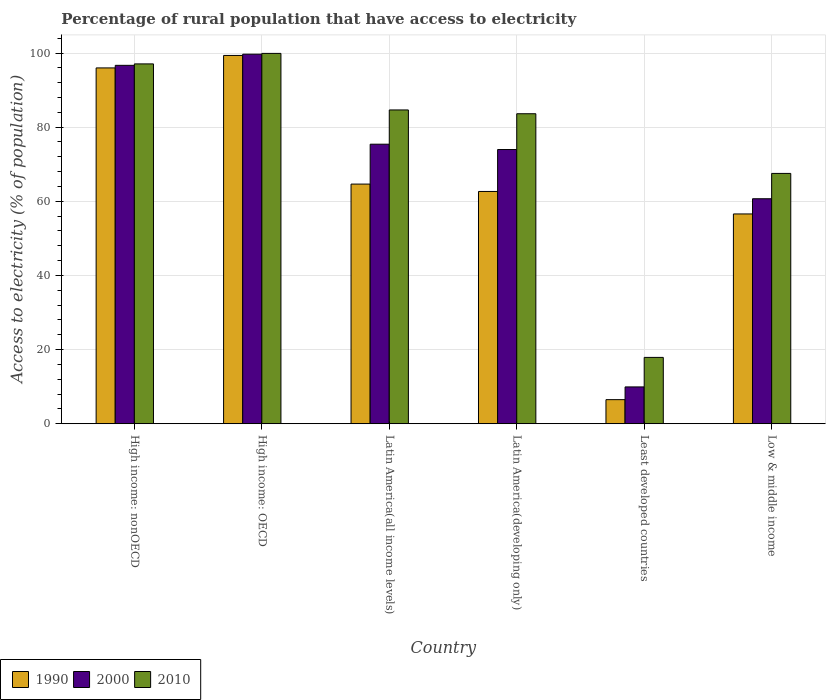How many different coloured bars are there?
Your answer should be very brief. 3. Are the number of bars on each tick of the X-axis equal?
Make the answer very short. Yes. How many bars are there on the 1st tick from the right?
Provide a succinct answer. 3. What is the label of the 5th group of bars from the left?
Make the answer very short. Least developed countries. In how many cases, is the number of bars for a given country not equal to the number of legend labels?
Provide a short and direct response. 0. What is the percentage of rural population that have access to electricity in 1990 in Least developed countries?
Your answer should be compact. 6.5. Across all countries, what is the maximum percentage of rural population that have access to electricity in 1990?
Provide a short and direct response. 99.34. Across all countries, what is the minimum percentage of rural population that have access to electricity in 1990?
Your response must be concise. 6.5. In which country was the percentage of rural population that have access to electricity in 1990 maximum?
Your answer should be very brief. High income: OECD. In which country was the percentage of rural population that have access to electricity in 2010 minimum?
Your answer should be compact. Least developed countries. What is the total percentage of rural population that have access to electricity in 1990 in the graph?
Your answer should be very brief. 385.7. What is the difference between the percentage of rural population that have access to electricity in 2000 in Least developed countries and that in Low & middle income?
Ensure brevity in your answer.  -50.76. What is the difference between the percentage of rural population that have access to electricity in 2000 in Low & middle income and the percentage of rural population that have access to electricity in 1990 in High income: nonOECD?
Keep it short and to the point. -35.29. What is the average percentage of rural population that have access to electricity in 1990 per country?
Keep it short and to the point. 64.28. What is the difference between the percentage of rural population that have access to electricity of/in 2000 and percentage of rural population that have access to electricity of/in 2010 in Latin America(all income levels)?
Keep it short and to the point. -9.24. In how many countries, is the percentage of rural population that have access to electricity in 2000 greater than 76 %?
Your answer should be very brief. 2. What is the ratio of the percentage of rural population that have access to electricity in 1990 in High income: OECD to that in High income: nonOECD?
Offer a terse response. 1.04. Is the percentage of rural population that have access to electricity in 1990 in High income: nonOECD less than that in Low & middle income?
Provide a short and direct response. No. What is the difference between the highest and the second highest percentage of rural population that have access to electricity in 2000?
Offer a very short reply. 21.27. What is the difference between the highest and the lowest percentage of rural population that have access to electricity in 2000?
Your answer should be very brief. 89.75. In how many countries, is the percentage of rural population that have access to electricity in 2000 greater than the average percentage of rural population that have access to electricity in 2000 taken over all countries?
Give a very brief answer. 4. What does the 3rd bar from the right in Least developed countries represents?
Provide a succinct answer. 1990. Is it the case that in every country, the sum of the percentage of rural population that have access to electricity in 2000 and percentage of rural population that have access to electricity in 2010 is greater than the percentage of rural population that have access to electricity in 1990?
Offer a terse response. Yes. What is the difference between two consecutive major ticks on the Y-axis?
Ensure brevity in your answer.  20. Are the values on the major ticks of Y-axis written in scientific E-notation?
Your response must be concise. No. Where does the legend appear in the graph?
Provide a succinct answer. Bottom left. What is the title of the graph?
Your answer should be very brief. Percentage of rural population that have access to electricity. What is the label or title of the Y-axis?
Ensure brevity in your answer.  Access to electricity (% of population). What is the Access to electricity (% of population) of 1990 in High income: nonOECD?
Give a very brief answer. 95.98. What is the Access to electricity (% of population) of 2000 in High income: nonOECD?
Your response must be concise. 96.68. What is the Access to electricity (% of population) in 2010 in High income: nonOECD?
Make the answer very short. 97.06. What is the Access to electricity (% of population) of 1990 in High income: OECD?
Your answer should be compact. 99.34. What is the Access to electricity (% of population) of 2000 in High income: OECD?
Your response must be concise. 99.68. What is the Access to electricity (% of population) in 2010 in High income: OECD?
Keep it short and to the point. 99.9. What is the Access to electricity (% of population) of 1990 in Latin America(all income levels)?
Make the answer very short. 64.64. What is the Access to electricity (% of population) in 2000 in Latin America(all income levels)?
Offer a terse response. 75.4. What is the Access to electricity (% of population) of 2010 in Latin America(all income levels)?
Ensure brevity in your answer.  84.64. What is the Access to electricity (% of population) in 1990 in Latin America(developing only)?
Provide a short and direct response. 62.65. What is the Access to electricity (% of population) of 2000 in Latin America(developing only)?
Ensure brevity in your answer.  73.97. What is the Access to electricity (% of population) of 2010 in Latin America(developing only)?
Make the answer very short. 83.62. What is the Access to electricity (% of population) of 1990 in Least developed countries?
Give a very brief answer. 6.5. What is the Access to electricity (% of population) of 2000 in Least developed countries?
Keep it short and to the point. 9.93. What is the Access to electricity (% of population) in 2010 in Least developed countries?
Offer a terse response. 17.89. What is the Access to electricity (% of population) in 1990 in Low & middle income?
Offer a terse response. 56.59. What is the Access to electricity (% of population) in 2000 in Low & middle income?
Your answer should be compact. 60.69. What is the Access to electricity (% of population) in 2010 in Low & middle income?
Provide a short and direct response. 67.52. Across all countries, what is the maximum Access to electricity (% of population) of 1990?
Provide a succinct answer. 99.34. Across all countries, what is the maximum Access to electricity (% of population) of 2000?
Offer a terse response. 99.68. Across all countries, what is the maximum Access to electricity (% of population) in 2010?
Provide a succinct answer. 99.9. Across all countries, what is the minimum Access to electricity (% of population) in 1990?
Offer a very short reply. 6.5. Across all countries, what is the minimum Access to electricity (% of population) of 2000?
Your answer should be very brief. 9.93. Across all countries, what is the minimum Access to electricity (% of population) of 2010?
Ensure brevity in your answer.  17.89. What is the total Access to electricity (% of population) in 1990 in the graph?
Offer a terse response. 385.7. What is the total Access to electricity (% of population) of 2000 in the graph?
Offer a very short reply. 416.35. What is the total Access to electricity (% of population) of 2010 in the graph?
Offer a terse response. 450.63. What is the difference between the Access to electricity (% of population) in 1990 in High income: nonOECD and that in High income: OECD?
Your answer should be compact. -3.37. What is the difference between the Access to electricity (% of population) of 2000 in High income: nonOECD and that in High income: OECD?
Your response must be concise. -3.01. What is the difference between the Access to electricity (% of population) in 2010 in High income: nonOECD and that in High income: OECD?
Your answer should be compact. -2.83. What is the difference between the Access to electricity (% of population) of 1990 in High income: nonOECD and that in Latin America(all income levels)?
Provide a succinct answer. 31.33. What is the difference between the Access to electricity (% of population) in 2000 in High income: nonOECD and that in Latin America(all income levels)?
Make the answer very short. 21.27. What is the difference between the Access to electricity (% of population) in 2010 in High income: nonOECD and that in Latin America(all income levels)?
Provide a succinct answer. 12.42. What is the difference between the Access to electricity (% of population) of 1990 in High income: nonOECD and that in Latin America(developing only)?
Give a very brief answer. 33.33. What is the difference between the Access to electricity (% of population) in 2000 in High income: nonOECD and that in Latin America(developing only)?
Your answer should be compact. 22.71. What is the difference between the Access to electricity (% of population) of 2010 in High income: nonOECD and that in Latin America(developing only)?
Make the answer very short. 13.44. What is the difference between the Access to electricity (% of population) of 1990 in High income: nonOECD and that in Least developed countries?
Offer a terse response. 89.48. What is the difference between the Access to electricity (% of population) of 2000 in High income: nonOECD and that in Least developed countries?
Make the answer very short. 86.75. What is the difference between the Access to electricity (% of population) in 2010 in High income: nonOECD and that in Least developed countries?
Give a very brief answer. 79.17. What is the difference between the Access to electricity (% of population) in 1990 in High income: nonOECD and that in Low & middle income?
Give a very brief answer. 39.39. What is the difference between the Access to electricity (% of population) of 2000 in High income: nonOECD and that in Low & middle income?
Make the answer very short. 35.99. What is the difference between the Access to electricity (% of population) of 2010 in High income: nonOECD and that in Low & middle income?
Provide a short and direct response. 29.54. What is the difference between the Access to electricity (% of population) of 1990 in High income: OECD and that in Latin America(all income levels)?
Your answer should be very brief. 34.7. What is the difference between the Access to electricity (% of population) in 2000 in High income: OECD and that in Latin America(all income levels)?
Your answer should be very brief. 24.28. What is the difference between the Access to electricity (% of population) of 2010 in High income: OECD and that in Latin America(all income levels)?
Your answer should be compact. 15.25. What is the difference between the Access to electricity (% of population) in 1990 in High income: OECD and that in Latin America(developing only)?
Your response must be concise. 36.69. What is the difference between the Access to electricity (% of population) in 2000 in High income: OECD and that in Latin America(developing only)?
Provide a succinct answer. 25.72. What is the difference between the Access to electricity (% of population) in 2010 in High income: OECD and that in Latin America(developing only)?
Ensure brevity in your answer.  16.28. What is the difference between the Access to electricity (% of population) in 1990 in High income: OECD and that in Least developed countries?
Keep it short and to the point. 92.84. What is the difference between the Access to electricity (% of population) in 2000 in High income: OECD and that in Least developed countries?
Provide a succinct answer. 89.75. What is the difference between the Access to electricity (% of population) of 2010 in High income: OECD and that in Least developed countries?
Ensure brevity in your answer.  82. What is the difference between the Access to electricity (% of population) in 1990 in High income: OECD and that in Low & middle income?
Provide a short and direct response. 42.75. What is the difference between the Access to electricity (% of population) of 2000 in High income: OECD and that in Low & middle income?
Provide a short and direct response. 39. What is the difference between the Access to electricity (% of population) in 2010 in High income: OECD and that in Low & middle income?
Give a very brief answer. 32.38. What is the difference between the Access to electricity (% of population) of 1990 in Latin America(all income levels) and that in Latin America(developing only)?
Give a very brief answer. 1.99. What is the difference between the Access to electricity (% of population) in 2000 in Latin America(all income levels) and that in Latin America(developing only)?
Ensure brevity in your answer.  1.44. What is the difference between the Access to electricity (% of population) in 2010 in Latin America(all income levels) and that in Latin America(developing only)?
Offer a terse response. 1.02. What is the difference between the Access to electricity (% of population) of 1990 in Latin America(all income levels) and that in Least developed countries?
Provide a short and direct response. 58.14. What is the difference between the Access to electricity (% of population) of 2000 in Latin America(all income levels) and that in Least developed countries?
Give a very brief answer. 65.47. What is the difference between the Access to electricity (% of population) of 2010 in Latin America(all income levels) and that in Least developed countries?
Your response must be concise. 66.75. What is the difference between the Access to electricity (% of population) of 1990 in Latin America(all income levels) and that in Low & middle income?
Provide a succinct answer. 8.05. What is the difference between the Access to electricity (% of population) of 2000 in Latin America(all income levels) and that in Low & middle income?
Your answer should be compact. 14.72. What is the difference between the Access to electricity (% of population) of 2010 in Latin America(all income levels) and that in Low & middle income?
Your response must be concise. 17.12. What is the difference between the Access to electricity (% of population) in 1990 in Latin America(developing only) and that in Least developed countries?
Make the answer very short. 56.15. What is the difference between the Access to electricity (% of population) in 2000 in Latin America(developing only) and that in Least developed countries?
Your answer should be very brief. 64.04. What is the difference between the Access to electricity (% of population) in 2010 in Latin America(developing only) and that in Least developed countries?
Your answer should be very brief. 65.73. What is the difference between the Access to electricity (% of population) in 1990 in Latin America(developing only) and that in Low & middle income?
Give a very brief answer. 6.06. What is the difference between the Access to electricity (% of population) in 2000 in Latin America(developing only) and that in Low & middle income?
Provide a succinct answer. 13.28. What is the difference between the Access to electricity (% of population) of 2010 in Latin America(developing only) and that in Low & middle income?
Keep it short and to the point. 16.1. What is the difference between the Access to electricity (% of population) of 1990 in Least developed countries and that in Low & middle income?
Your response must be concise. -50.09. What is the difference between the Access to electricity (% of population) of 2000 in Least developed countries and that in Low & middle income?
Make the answer very short. -50.76. What is the difference between the Access to electricity (% of population) in 2010 in Least developed countries and that in Low & middle income?
Keep it short and to the point. -49.63. What is the difference between the Access to electricity (% of population) in 1990 in High income: nonOECD and the Access to electricity (% of population) in 2000 in High income: OECD?
Provide a short and direct response. -3.71. What is the difference between the Access to electricity (% of population) of 1990 in High income: nonOECD and the Access to electricity (% of population) of 2010 in High income: OECD?
Make the answer very short. -3.92. What is the difference between the Access to electricity (% of population) of 2000 in High income: nonOECD and the Access to electricity (% of population) of 2010 in High income: OECD?
Ensure brevity in your answer.  -3.22. What is the difference between the Access to electricity (% of population) of 1990 in High income: nonOECD and the Access to electricity (% of population) of 2000 in Latin America(all income levels)?
Offer a very short reply. 20.57. What is the difference between the Access to electricity (% of population) of 1990 in High income: nonOECD and the Access to electricity (% of population) of 2010 in Latin America(all income levels)?
Offer a very short reply. 11.34. What is the difference between the Access to electricity (% of population) of 2000 in High income: nonOECD and the Access to electricity (% of population) of 2010 in Latin America(all income levels)?
Your answer should be very brief. 12.03. What is the difference between the Access to electricity (% of population) of 1990 in High income: nonOECD and the Access to electricity (% of population) of 2000 in Latin America(developing only)?
Provide a short and direct response. 22.01. What is the difference between the Access to electricity (% of population) in 1990 in High income: nonOECD and the Access to electricity (% of population) in 2010 in Latin America(developing only)?
Your response must be concise. 12.36. What is the difference between the Access to electricity (% of population) of 2000 in High income: nonOECD and the Access to electricity (% of population) of 2010 in Latin America(developing only)?
Provide a short and direct response. 13.06. What is the difference between the Access to electricity (% of population) in 1990 in High income: nonOECD and the Access to electricity (% of population) in 2000 in Least developed countries?
Give a very brief answer. 86.05. What is the difference between the Access to electricity (% of population) of 1990 in High income: nonOECD and the Access to electricity (% of population) of 2010 in Least developed countries?
Offer a terse response. 78.08. What is the difference between the Access to electricity (% of population) of 2000 in High income: nonOECD and the Access to electricity (% of population) of 2010 in Least developed countries?
Your answer should be very brief. 78.78. What is the difference between the Access to electricity (% of population) of 1990 in High income: nonOECD and the Access to electricity (% of population) of 2000 in Low & middle income?
Your answer should be very brief. 35.29. What is the difference between the Access to electricity (% of population) in 1990 in High income: nonOECD and the Access to electricity (% of population) in 2010 in Low & middle income?
Offer a very short reply. 28.46. What is the difference between the Access to electricity (% of population) in 2000 in High income: nonOECD and the Access to electricity (% of population) in 2010 in Low & middle income?
Keep it short and to the point. 29.16. What is the difference between the Access to electricity (% of population) of 1990 in High income: OECD and the Access to electricity (% of population) of 2000 in Latin America(all income levels)?
Offer a terse response. 23.94. What is the difference between the Access to electricity (% of population) in 1990 in High income: OECD and the Access to electricity (% of population) in 2010 in Latin America(all income levels)?
Make the answer very short. 14.7. What is the difference between the Access to electricity (% of population) of 2000 in High income: OECD and the Access to electricity (% of population) of 2010 in Latin America(all income levels)?
Make the answer very short. 15.04. What is the difference between the Access to electricity (% of population) in 1990 in High income: OECD and the Access to electricity (% of population) in 2000 in Latin America(developing only)?
Make the answer very short. 25.38. What is the difference between the Access to electricity (% of population) in 1990 in High income: OECD and the Access to electricity (% of population) in 2010 in Latin America(developing only)?
Keep it short and to the point. 15.72. What is the difference between the Access to electricity (% of population) in 2000 in High income: OECD and the Access to electricity (% of population) in 2010 in Latin America(developing only)?
Your answer should be very brief. 16.07. What is the difference between the Access to electricity (% of population) in 1990 in High income: OECD and the Access to electricity (% of population) in 2000 in Least developed countries?
Your answer should be very brief. 89.41. What is the difference between the Access to electricity (% of population) in 1990 in High income: OECD and the Access to electricity (% of population) in 2010 in Least developed countries?
Make the answer very short. 81.45. What is the difference between the Access to electricity (% of population) of 2000 in High income: OECD and the Access to electricity (% of population) of 2010 in Least developed countries?
Your answer should be very brief. 81.79. What is the difference between the Access to electricity (% of population) of 1990 in High income: OECD and the Access to electricity (% of population) of 2000 in Low & middle income?
Your answer should be compact. 38.65. What is the difference between the Access to electricity (% of population) of 1990 in High income: OECD and the Access to electricity (% of population) of 2010 in Low & middle income?
Provide a succinct answer. 31.82. What is the difference between the Access to electricity (% of population) in 2000 in High income: OECD and the Access to electricity (% of population) in 2010 in Low & middle income?
Provide a short and direct response. 32.16. What is the difference between the Access to electricity (% of population) in 1990 in Latin America(all income levels) and the Access to electricity (% of population) in 2000 in Latin America(developing only)?
Your answer should be compact. -9.32. What is the difference between the Access to electricity (% of population) in 1990 in Latin America(all income levels) and the Access to electricity (% of population) in 2010 in Latin America(developing only)?
Make the answer very short. -18.98. What is the difference between the Access to electricity (% of population) of 2000 in Latin America(all income levels) and the Access to electricity (% of population) of 2010 in Latin America(developing only)?
Provide a short and direct response. -8.21. What is the difference between the Access to electricity (% of population) of 1990 in Latin America(all income levels) and the Access to electricity (% of population) of 2000 in Least developed countries?
Your answer should be compact. 54.71. What is the difference between the Access to electricity (% of population) of 1990 in Latin America(all income levels) and the Access to electricity (% of population) of 2010 in Least developed countries?
Provide a succinct answer. 46.75. What is the difference between the Access to electricity (% of population) of 2000 in Latin America(all income levels) and the Access to electricity (% of population) of 2010 in Least developed countries?
Make the answer very short. 57.51. What is the difference between the Access to electricity (% of population) in 1990 in Latin America(all income levels) and the Access to electricity (% of population) in 2000 in Low & middle income?
Offer a very short reply. 3.95. What is the difference between the Access to electricity (% of population) of 1990 in Latin America(all income levels) and the Access to electricity (% of population) of 2010 in Low & middle income?
Provide a succinct answer. -2.88. What is the difference between the Access to electricity (% of population) in 2000 in Latin America(all income levels) and the Access to electricity (% of population) in 2010 in Low & middle income?
Make the answer very short. 7.88. What is the difference between the Access to electricity (% of population) in 1990 in Latin America(developing only) and the Access to electricity (% of population) in 2000 in Least developed countries?
Your answer should be very brief. 52.72. What is the difference between the Access to electricity (% of population) in 1990 in Latin America(developing only) and the Access to electricity (% of population) in 2010 in Least developed countries?
Offer a very short reply. 44.76. What is the difference between the Access to electricity (% of population) in 2000 in Latin America(developing only) and the Access to electricity (% of population) in 2010 in Least developed countries?
Give a very brief answer. 56.07. What is the difference between the Access to electricity (% of population) of 1990 in Latin America(developing only) and the Access to electricity (% of population) of 2000 in Low & middle income?
Your answer should be compact. 1.96. What is the difference between the Access to electricity (% of population) in 1990 in Latin America(developing only) and the Access to electricity (% of population) in 2010 in Low & middle income?
Your response must be concise. -4.87. What is the difference between the Access to electricity (% of population) of 2000 in Latin America(developing only) and the Access to electricity (% of population) of 2010 in Low & middle income?
Your answer should be very brief. 6.45. What is the difference between the Access to electricity (% of population) in 1990 in Least developed countries and the Access to electricity (% of population) in 2000 in Low & middle income?
Ensure brevity in your answer.  -54.19. What is the difference between the Access to electricity (% of population) of 1990 in Least developed countries and the Access to electricity (% of population) of 2010 in Low & middle income?
Provide a succinct answer. -61.02. What is the difference between the Access to electricity (% of population) of 2000 in Least developed countries and the Access to electricity (% of population) of 2010 in Low & middle income?
Ensure brevity in your answer.  -57.59. What is the average Access to electricity (% of population) of 1990 per country?
Your answer should be compact. 64.28. What is the average Access to electricity (% of population) in 2000 per country?
Ensure brevity in your answer.  69.39. What is the average Access to electricity (% of population) of 2010 per country?
Provide a succinct answer. 75.11. What is the difference between the Access to electricity (% of population) in 1990 and Access to electricity (% of population) in 2000 in High income: nonOECD?
Your answer should be compact. -0.7. What is the difference between the Access to electricity (% of population) of 1990 and Access to electricity (% of population) of 2010 in High income: nonOECD?
Provide a succinct answer. -1.08. What is the difference between the Access to electricity (% of population) of 2000 and Access to electricity (% of population) of 2010 in High income: nonOECD?
Keep it short and to the point. -0.39. What is the difference between the Access to electricity (% of population) of 1990 and Access to electricity (% of population) of 2000 in High income: OECD?
Offer a very short reply. -0.34. What is the difference between the Access to electricity (% of population) in 1990 and Access to electricity (% of population) in 2010 in High income: OECD?
Ensure brevity in your answer.  -0.55. What is the difference between the Access to electricity (% of population) in 2000 and Access to electricity (% of population) in 2010 in High income: OECD?
Make the answer very short. -0.21. What is the difference between the Access to electricity (% of population) of 1990 and Access to electricity (% of population) of 2000 in Latin America(all income levels)?
Your response must be concise. -10.76. What is the difference between the Access to electricity (% of population) in 1990 and Access to electricity (% of population) in 2010 in Latin America(all income levels)?
Ensure brevity in your answer.  -20. What is the difference between the Access to electricity (% of population) in 2000 and Access to electricity (% of population) in 2010 in Latin America(all income levels)?
Provide a short and direct response. -9.24. What is the difference between the Access to electricity (% of population) of 1990 and Access to electricity (% of population) of 2000 in Latin America(developing only)?
Offer a very short reply. -11.32. What is the difference between the Access to electricity (% of population) in 1990 and Access to electricity (% of population) in 2010 in Latin America(developing only)?
Offer a terse response. -20.97. What is the difference between the Access to electricity (% of population) in 2000 and Access to electricity (% of population) in 2010 in Latin America(developing only)?
Give a very brief answer. -9.65. What is the difference between the Access to electricity (% of population) of 1990 and Access to electricity (% of population) of 2000 in Least developed countries?
Your answer should be very brief. -3.43. What is the difference between the Access to electricity (% of population) in 1990 and Access to electricity (% of population) in 2010 in Least developed countries?
Provide a short and direct response. -11.4. What is the difference between the Access to electricity (% of population) in 2000 and Access to electricity (% of population) in 2010 in Least developed countries?
Provide a short and direct response. -7.96. What is the difference between the Access to electricity (% of population) of 1990 and Access to electricity (% of population) of 2000 in Low & middle income?
Your answer should be very brief. -4.1. What is the difference between the Access to electricity (% of population) of 1990 and Access to electricity (% of population) of 2010 in Low & middle income?
Your response must be concise. -10.93. What is the difference between the Access to electricity (% of population) in 2000 and Access to electricity (% of population) in 2010 in Low & middle income?
Your answer should be compact. -6.83. What is the ratio of the Access to electricity (% of population) in 1990 in High income: nonOECD to that in High income: OECD?
Provide a succinct answer. 0.97. What is the ratio of the Access to electricity (% of population) of 2000 in High income: nonOECD to that in High income: OECD?
Make the answer very short. 0.97. What is the ratio of the Access to electricity (% of population) in 2010 in High income: nonOECD to that in High income: OECD?
Make the answer very short. 0.97. What is the ratio of the Access to electricity (% of population) of 1990 in High income: nonOECD to that in Latin America(all income levels)?
Keep it short and to the point. 1.48. What is the ratio of the Access to electricity (% of population) in 2000 in High income: nonOECD to that in Latin America(all income levels)?
Your answer should be very brief. 1.28. What is the ratio of the Access to electricity (% of population) in 2010 in High income: nonOECD to that in Latin America(all income levels)?
Offer a very short reply. 1.15. What is the ratio of the Access to electricity (% of population) of 1990 in High income: nonOECD to that in Latin America(developing only)?
Provide a short and direct response. 1.53. What is the ratio of the Access to electricity (% of population) of 2000 in High income: nonOECD to that in Latin America(developing only)?
Your answer should be very brief. 1.31. What is the ratio of the Access to electricity (% of population) of 2010 in High income: nonOECD to that in Latin America(developing only)?
Your answer should be compact. 1.16. What is the ratio of the Access to electricity (% of population) of 1990 in High income: nonOECD to that in Least developed countries?
Your answer should be very brief. 14.77. What is the ratio of the Access to electricity (% of population) in 2000 in High income: nonOECD to that in Least developed countries?
Give a very brief answer. 9.73. What is the ratio of the Access to electricity (% of population) of 2010 in High income: nonOECD to that in Least developed countries?
Ensure brevity in your answer.  5.42. What is the ratio of the Access to electricity (% of population) of 1990 in High income: nonOECD to that in Low & middle income?
Your response must be concise. 1.7. What is the ratio of the Access to electricity (% of population) in 2000 in High income: nonOECD to that in Low & middle income?
Your answer should be very brief. 1.59. What is the ratio of the Access to electricity (% of population) of 2010 in High income: nonOECD to that in Low & middle income?
Your response must be concise. 1.44. What is the ratio of the Access to electricity (% of population) of 1990 in High income: OECD to that in Latin America(all income levels)?
Your answer should be very brief. 1.54. What is the ratio of the Access to electricity (% of population) in 2000 in High income: OECD to that in Latin America(all income levels)?
Your answer should be very brief. 1.32. What is the ratio of the Access to electricity (% of population) in 2010 in High income: OECD to that in Latin America(all income levels)?
Offer a very short reply. 1.18. What is the ratio of the Access to electricity (% of population) of 1990 in High income: OECD to that in Latin America(developing only)?
Offer a very short reply. 1.59. What is the ratio of the Access to electricity (% of population) of 2000 in High income: OECD to that in Latin America(developing only)?
Provide a succinct answer. 1.35. What is the ratio of the Access to electricity (% of population) in 2010 in High income: OECD to that in Latin America(developing only)?
Your response must be concise. 1.19. What is the ratio of the Access to electricity (% of population) of 1990 in High income: OECD to that in Least developed countries?
Offer a terse response. 15.29. What is the ratio of the Access to electricity (% of population) in 2000 in High income: OECD to that in Least developed countries?
Make the answer very short. 10.04. What is the ratio of the Access to electricity (% of population) of 2010 in High income: OECD to that in Least developed countries?
Offer a very short reply. 5.58. What is the ratio of the Access to electricity (% of population) of 1990 in High income: OECD to that in Low & middle income?
Your response must be concise. 1.76. What is the ratio of the Access to electricity (% of population) in 2000 in High income: OECD to that in Low & middle income?
Offer a terse response. 1.64. What is the ratio of the Access to electricity (% of population) of 2010 in High income: OECD to that in Low & middle income?
Your response must be concise. 1.48. What is the ratio of the Access to electricity (% of population) of 1990 in Latin America(all income levels) to that in Latin America(developing only)?
Offer a terse response. 1.03. What is the ratio of the Access to electricity (% of population) of 2000 in Latin America(all income levels) to that in Latin America(developing only)?
Your answer should be very brief. 1.02. What is the ratio of the Access to electricity (% of population) of 2010 in Latin America(all income levels) to that in Latin America(developing only)?
Provide a succinct answer. 1.01. What is the ratio of the Access to electricity (% of population) in 1990 in Latin America(all income levels) to that in Least developed countries?
Offer a very short reply. 9.95. What is the ratio of the Access to electricity (% of population) of 2000 in Latin America(all income levels) to that in Least developed countries?
Give a very brief answer. 7.59. What is the ratio of the Access to electricity (% of population) in 2010 in Latin America(all income levels) to that in Least developed countries?
Your response must be concise. 4.73. What is the ratio of the Access to electricity (% of population) in 1990 in Latin America(all income levels) to that in Low & middle income?
Give a very brief answer. 1.14. What is the ratio of the Access to electricity (% of population) in 2000 in Latin America(all income levels) to that in Low & middle income?
Keep it short and to the point. 1.24. What is the ratio of the Access to electricity (% of population) in 2010 in Latin America(all income levels) to that in Low & middle income?
Offer a very short reply. 1.25. What is the ratio of the Access to electricity (% of population) of 1990 in Latin America(developing only) to that in Least developed countries?
Offer a very short reply. 9.64. What is the ratio of the Access to electricity (% of population) in 2000 in Latin America(developing only) to that in Least developed countries?
Ensure brevity in your answer.  7.45. What is the ratio of the Access to electricity (% of population) of 2010 in Latin America(developing only) to that in Least developed countries?
Your response must be concise. 4.67. What is the ratio of the Access to electricity (% of population) in 1990 in Latin America(developing only) to that in Low & middle income?
Offer a very short reply. 1.11. What is the ratio of the Access to electricity (% of population) of 2000 in Latin America(developing only) to that in Low & middle income?
Your answer should be compact. 1.22. What is the ratio of the Access to electricity (% of population) of 2010 in Latin America(developing only) to that in Low & middle income?
Offer a very short reply. 1.24. What is the ratio of the Access to electricity (% of population) of 1990 in Least developed countries to that in Low & middle income?
Give a very brief answer. 0.11. What is the ratio of the Access to electricity (% of population) in 2000 in Least developed countries to that in Low & middle income?
Provide a short and direct response. 0.16. What is the ratio of the Access to electricity (% of population) in 2010 in Least developed countries to that in Low & middle income?
Offer a terse response. 0.27. What is the difference between the highest and the second highest Access to electricity (% of population) in 1990?
Give a very brief answer. 3.37. What is the difference between the highest and the second highest Access to electricity (% of population) in 2000?
Provide a succinct answer. 3.01. What is the difference between the highest and the second highest Access to electricity (% of population) in 2010?
Your response must be concise. 2.83. What is the difference between the highest and the lowest Access to electricity (% of population) in 1990?
Your answer should be compact. 92.84. What is the difference between the highest and the lowest Access to electricity (% of population) of 2000?
Offer a terse response. 89.75. What is the difference between the highest and the lowest Access to electricity (% of population) of 2010?
Make the answer very short. 82. 